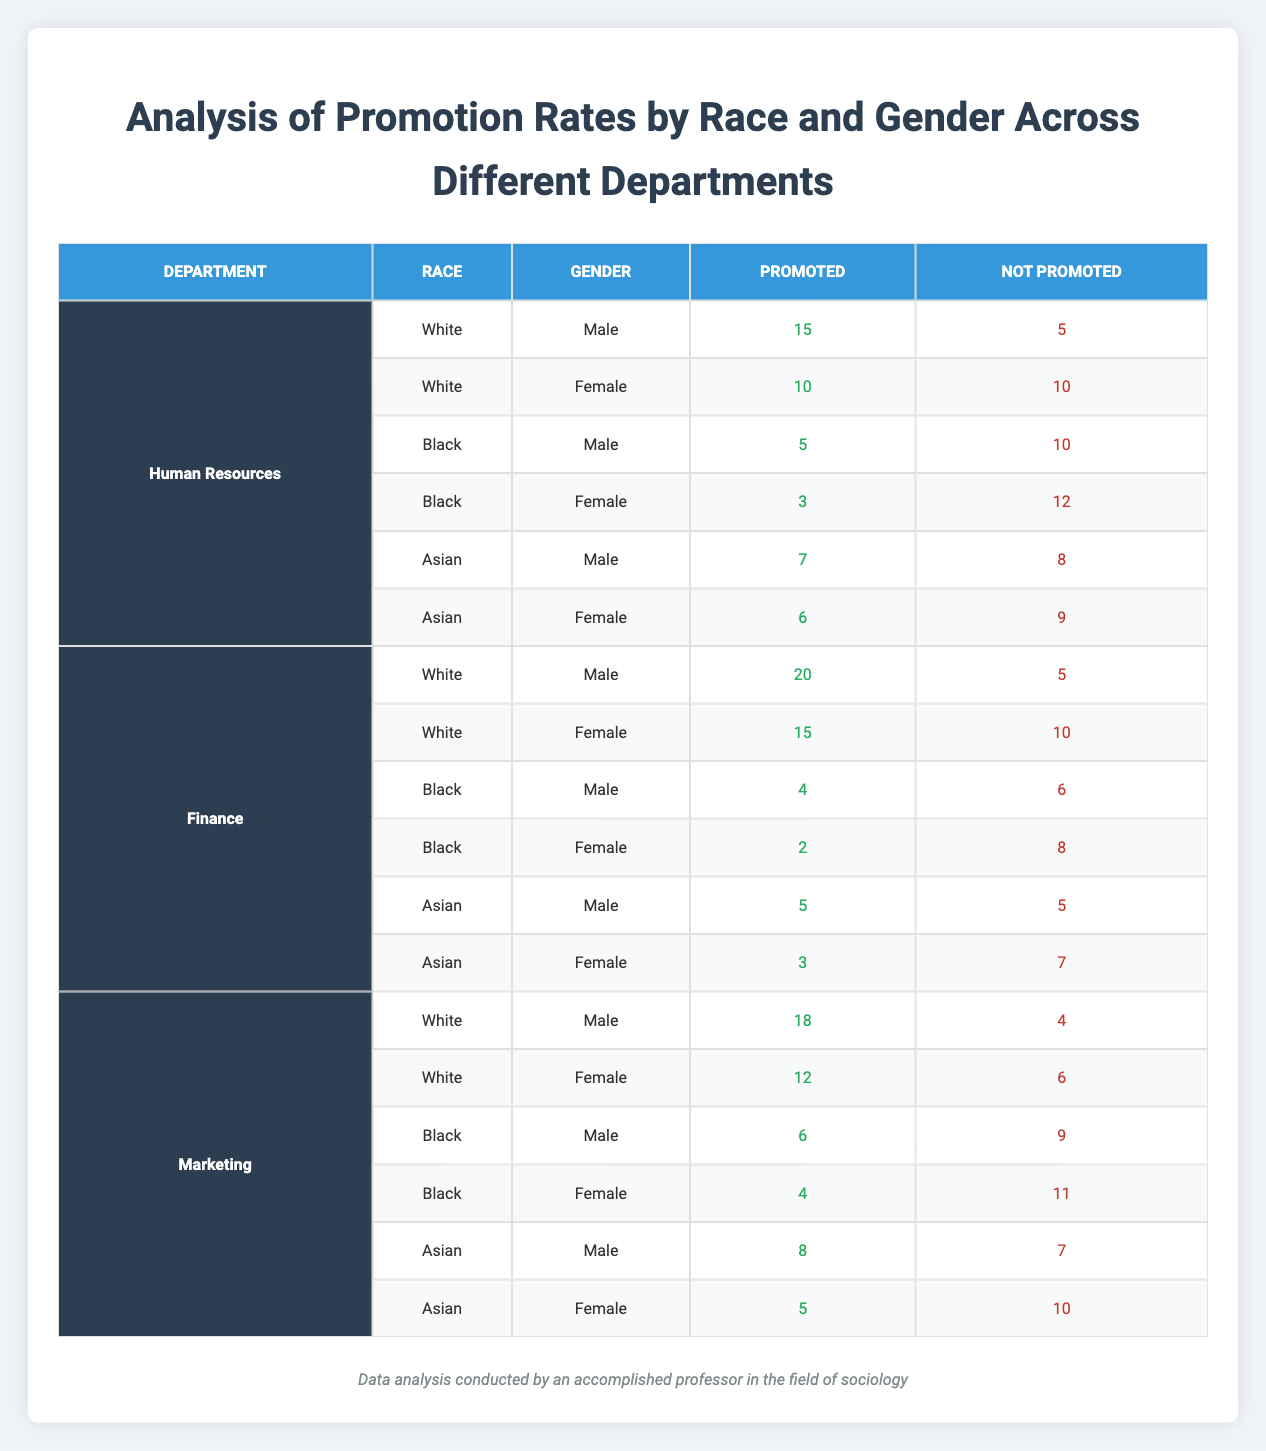What is the total number of promotions in the Finance department? To find the total number of promotions in the Finance department, we sum the Promoted values for all racial and gender combinations in the Finance section. This includes: White Male (20) + White Female (15) + Black Male (4) + Black Female (2) + Asian Male (5) + Asian Female (3) = 20 + 15 + 4 + 2 + 5 + 3 = 49.
Answer: 49 How many Asian males were promoted across all departments? There are three departments listed: Human Resources, Finance, and Marketing. The figures for Asian males promoted are: Human Resources (7), Finance (5), and Marketing (8). We sum these values to find the total: 7 + 5 + 8 = 20.
Answer: 20 Is it true that Asian females are promoted more often than Black males within the same department? In the Human Resources department, Asian females were promoted (6) compared to Black males (5). In the Finance department, Asian females had (3) promotions versus Black males (4). In Marketing, Asian females were promoted (5) against Black males (6). Thus, for Human Resources, yes, but for Finance and Marketing, no. Therefore, overall, it is not true.
Answer: No What is the average promotion rate for White females across all departments? To find the average promotion rate for White females, first gather the promotion numbers for this group: Human Resources (10), Finance (15), and Marketing (12). The total promotions for White females is 10 + 15 + 12 = 37. There are 3 data points, thus the average is 37 / 3 = 12.33, rounded can be reported as 12.
Answer: 12.33 Which department had the highest number of promotions for Black females, and what was that number? First, we look at the number of promotions for Black females in each department. Human Resources shows 3, Finance has 2, and Marketing has 4. The highest promotion number from these is 4 in the Marketing department.
Answer: Marketing, 4 What is the difference in promotion counts between White males and Asian males in the Marketing department? In the Marketing department, White males were promoted 18 times, while Asian males received 8 promotions. To find the difference, we subtract Asian male promotions from White male promotions: 18 - 8 = 10.
Answer: 10 How many total promotions were there for all Black employees across all departments? We need to sum the promotions for Black employees in each department: Black males in Human Resources (5), Finance (4), and Marketing (6), and Black females in Human Resources (3), Finance (2), and Marketing (4). To get the total, we calculate: 5 + 4 + 6 + 3 + 2 + 4 = 24.
Answer: 24 Are White females promoted more than Asian females across all departments combined? We tally promotions for White females: Human Resources (10), Finance (15), and Marketing (12), totalling 37. For Asian females, we have: Human Resources (6), Finance (3), and Marketing (5), totalling 14. Comparing these totals shows that White females (37) are promoted more than Asian females (14).
Answer: Yes 